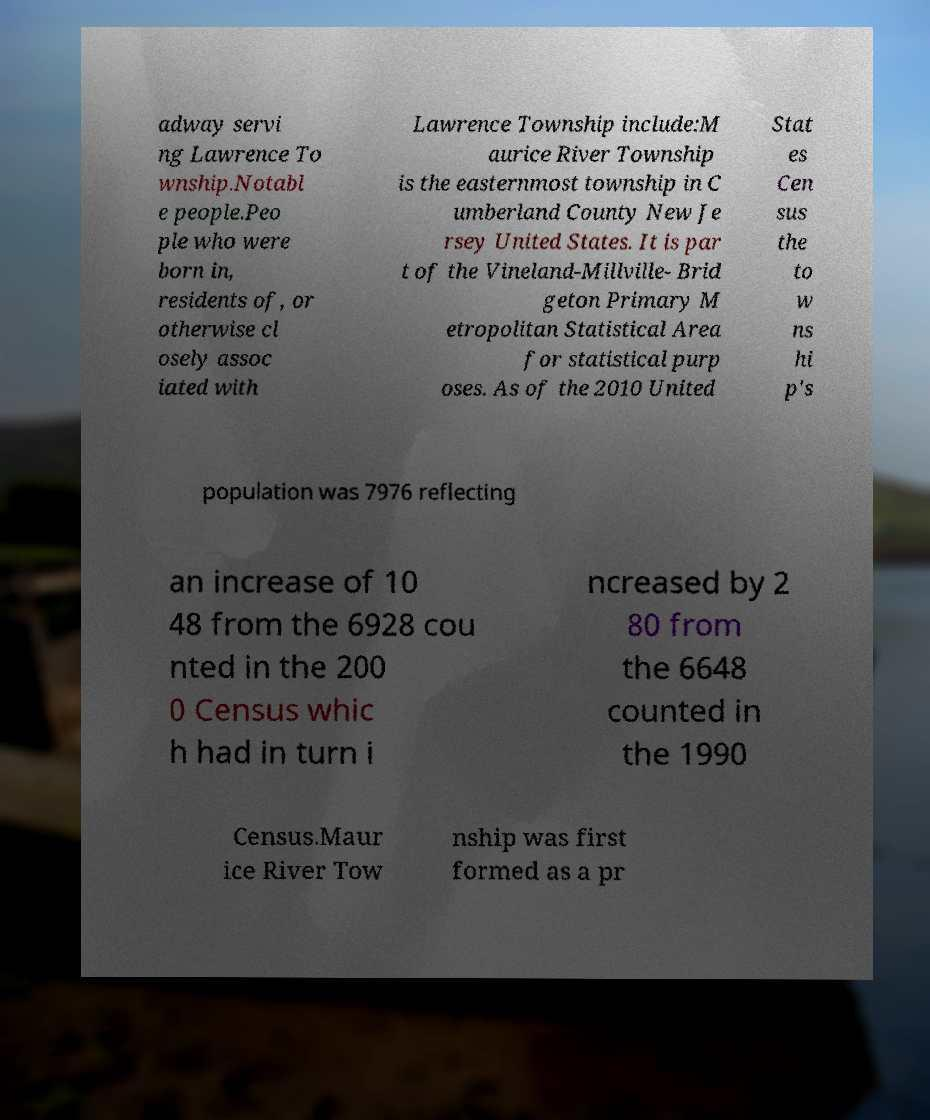For documentation purposes, I need the text within this image transcribed. Could you provide that? adway servi ng Lawrence To wnship.Notabl e people.Peo ple who were born in, residents of, or otherwise cl osely assoc iated with Lawrence Township include:M aurice River Township is the easternmost township in C umberland County New Je rsey United States. It is par t of the Vineland-Millville- Brid geton Primary M etropolitan Statistical Area for statistical purp oses. As of the 2010 United Stat es Cen sus the to w ns hi p's population was 7976 reflecting an increase of 10 48 from the 6928 cou nted in the 200 0 Census whic h had in turn i ncreased by 2 80 from the 6648 counted in the 1990 Census.Maur ice River Tow nship was first formed as a pr 